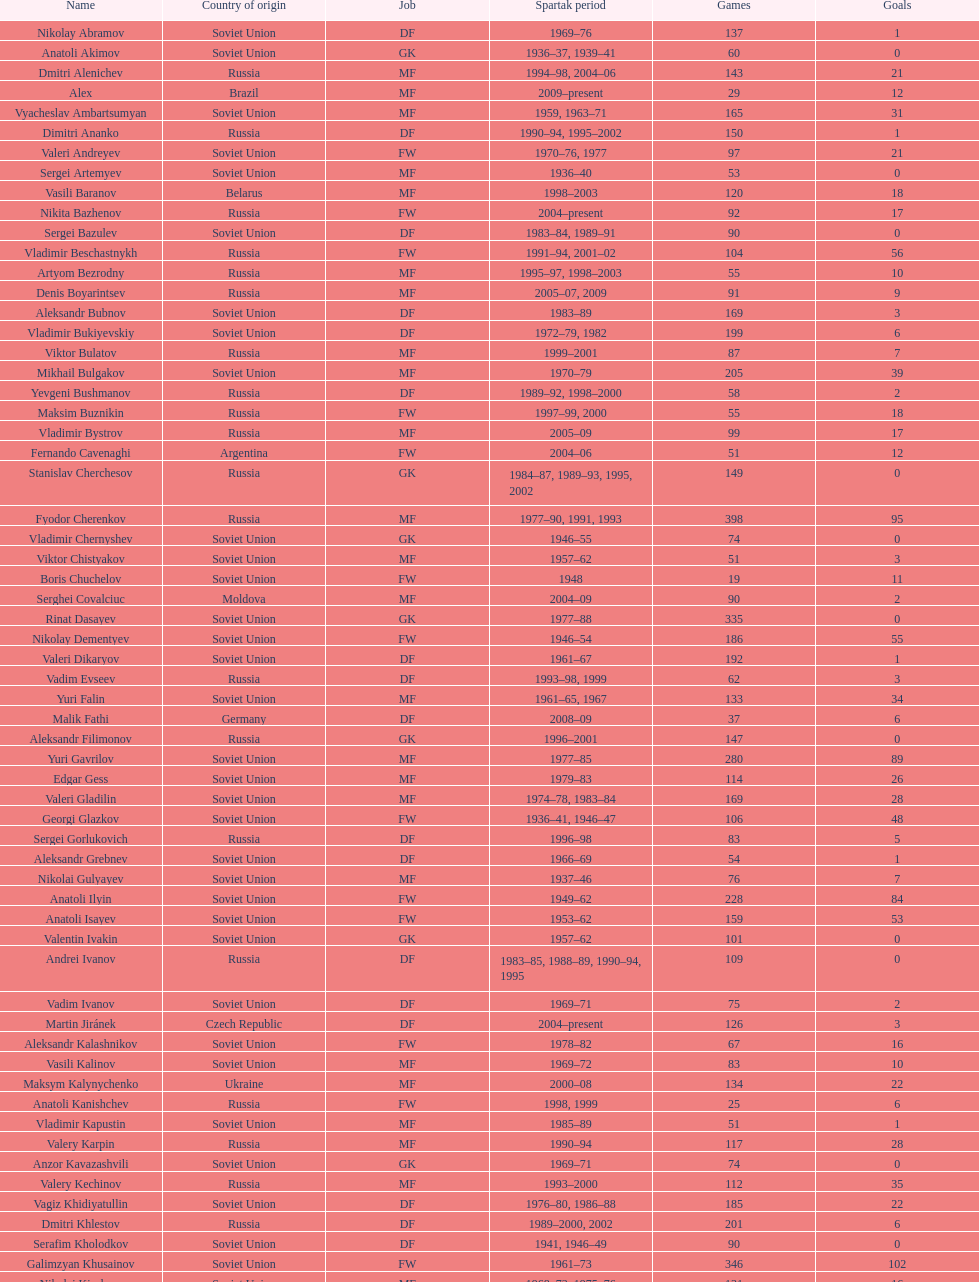How many players had at least 20 league goals scored? 56. 